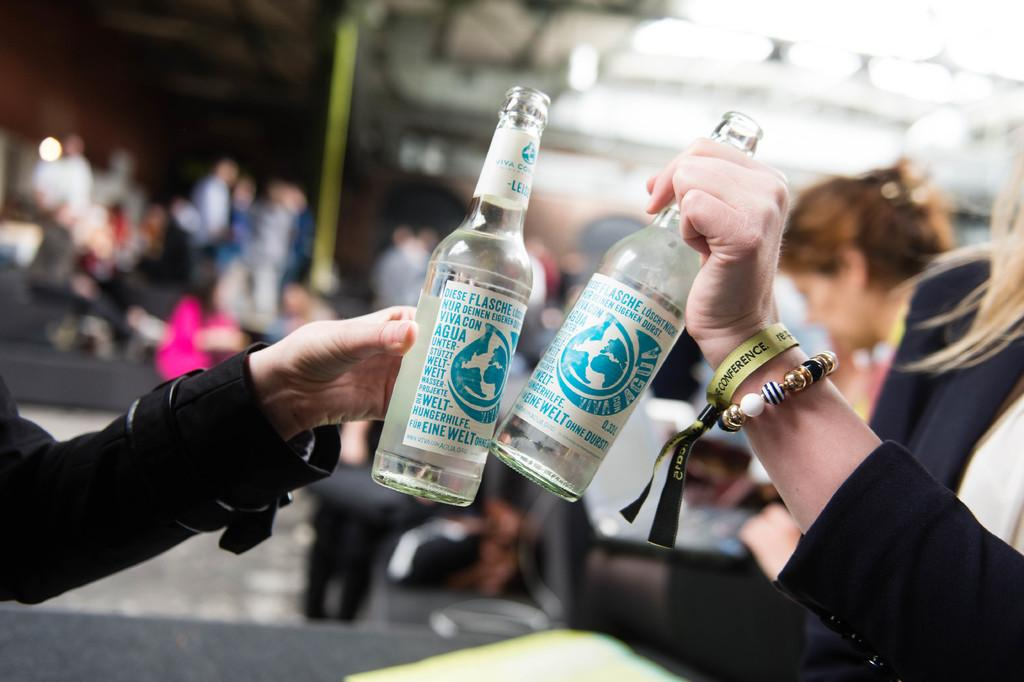How many people are present in the image? There are two persons in the image. What are the two persons holding in their hands? The two persons are holding bottles in their hands. Can you describe the background of the image? There are people in the background of the image. What type of tank can be seen in the image? There is no tank present in the image. In what year was the image taken? The year the image was taken is not mentioned in the provided facts. 